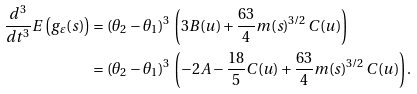Convert formula to latex. <formula><loc_0><loc_0><loc_500><loc_500>\frac { d ^ { 3 } } { d t ^ { 3 } } E \left ( g _ { \varepsilon } ( s ) \right ) & = ( \theta _ { 2 } - \theta _ { 1 } ) ^ { 3 } \, \left ( 3 B ( u ) + \frac { 6 3 } { 4 } m ( s ) ^ { 3 / 2 } \, C ( u ) \right ) \\ & = ( \theta _ { 2 } - \theta _ { 1 } ) ^ { 3 } \, \left ( - 2 A - \frac { 1 8 } { 5 } C ( u ) + \frac { 6 3 } { 4 } m ( s ) ^ { 3 / 2 } \, C ( u ) \right ) .</formula> 